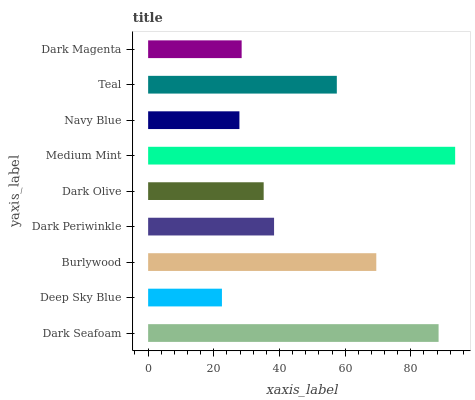Is Deep Sky Blue the minimum?
Answer yes or no. Yes. Is Medium Mint the maximum?
Answer yes or no. Yes. Is Burlywood the minimum?
Answer yes or no. No. Is Burlywood the maximum?
Answer yes or no. No. Is Burlywood greater than Deep Sky Blue?
Answer yes or no. Yes. Is Deep Sky Blue less than Burlywood?
Answer yes or no. Yes. Is Deep Sky Blue greater than Burlywood?
Answer yes or no. No. Is Burlywood less than Deep Sky Blue?
Answer yes or no. No. Is Dark Periwinkle the high median?
Answer yes or no. Yes. Is Dark Periwinkle the low median?
Answer yes or no. Yes. Is Navy Blue the high median?
Answer yes or no. No. Is Dark Olive the low median?
Answer yes or no. No. 